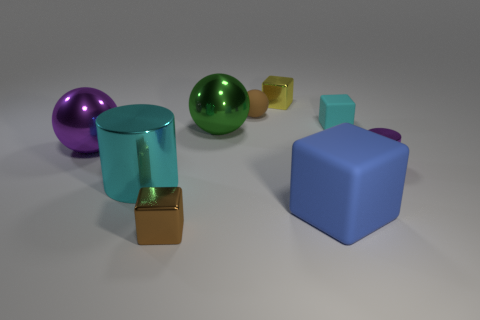Subtract all cylinders. How many objects are left? 7 Add 2 small green cubes. How many small green cubes exist? 2 Subtract 0 blue balls. How many objects are left? 9 Subtract all small yellow spheres. Subtract all small brown balls. How many objects are left? 8 Add 3 small shiny cubes. How many small shiny cubes are left? 5 